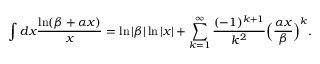<formula> <loc_0><loc_0><loc_500><loc_500>\int d x \frac { \ln ( \beta + \alpha x ) } { x } = \ln | \beta | \ln | x | + \sum _ { k = 1 } ^ { \infty } \frac { ( - 1 ) ^ { k + 1 } } { k ^ { 2 } } \left ( \frac { \alpha x } { \beta } \right ) ^ { k } .</formula> 